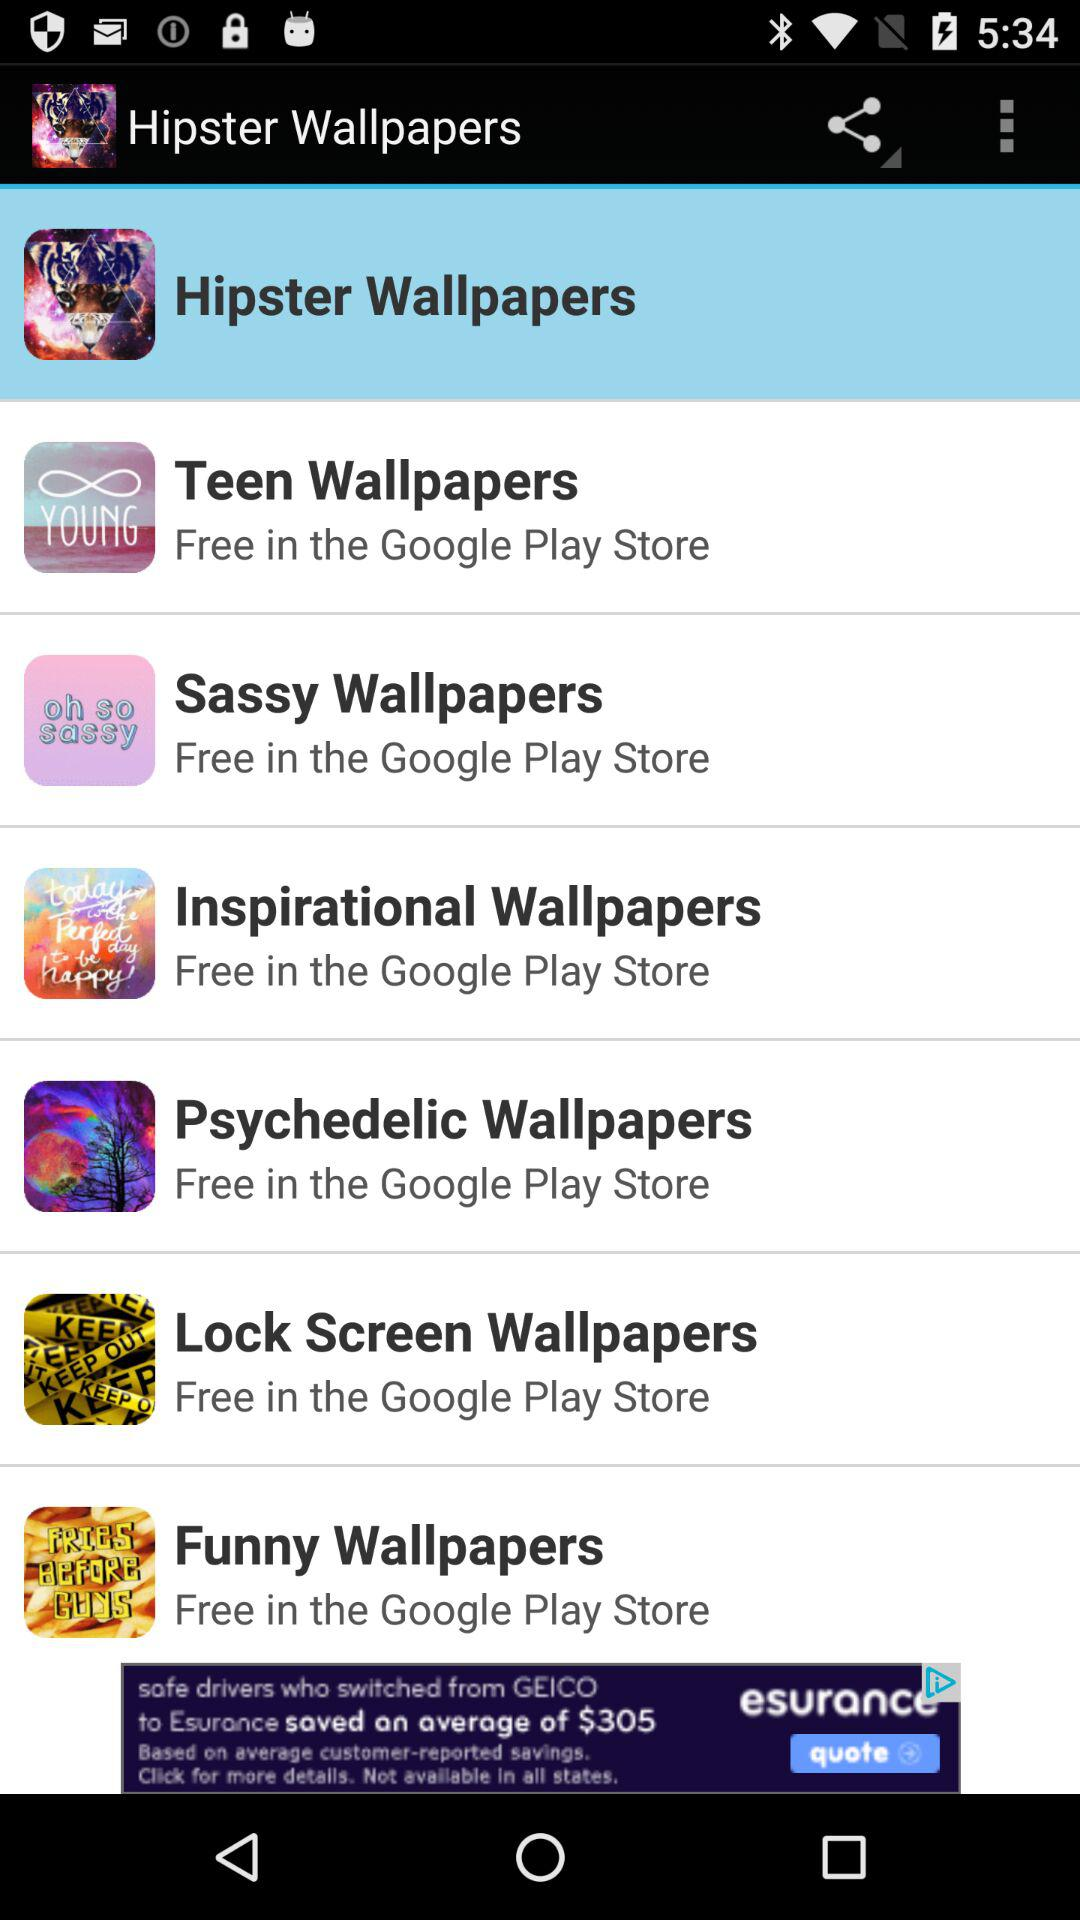How many more wallpapers are there in the 'Inspirational' category than in the 'Funny' category?
Answer the question using a single word or phrase. 1 